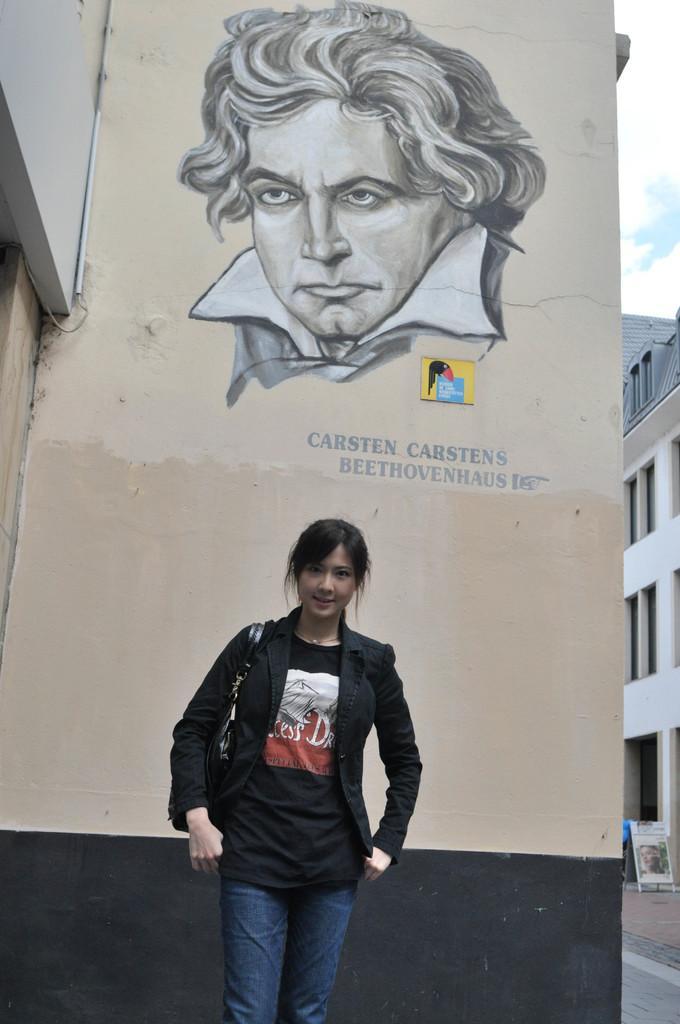In one or two sentences, can you explain what this image depicts? In this image we can see a person holding a bag. Behind the person there is a wall. On the wall there is a painting and text. On the right side of the image there are buildings, walkway, road and board. 